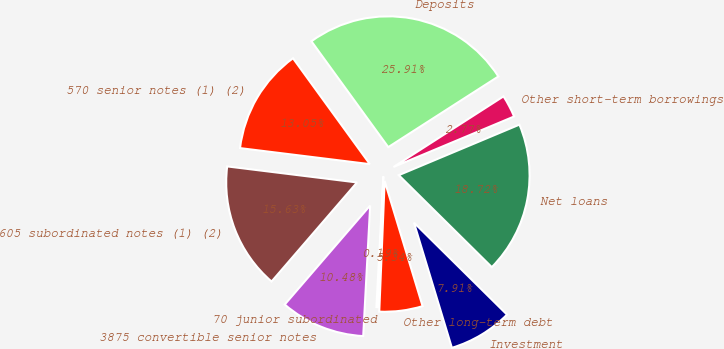Convert chart. <chart><loc_0><loc_0><loc_500><loc_500><pie_chart><fcel>Investment<fcel>Net loans<fcel>Other short-term borrowings<fcel>Deposits<fcel>570 senior notes (1) (2)<fcel>605 subordinated notes (1) (2)<fcel>3875 convertible senior notes<fcel>70 junior subordinated<fcel>Other long-term debt<nl><fcel>7.91%<fcel>18.72%<fcel>2.77%<fcel>25.91%<fcel>13.05%<fcel>15.63%<fcel>10.48%<fcel>0.19%<fcel>5.34%<nl></chart> 